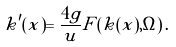<formula> <loc_0><loc_0><loc_500><loc_500>k ^ { \prime } ( x ) = \frac { 4 g } { u } F ( k ( x ) , \Omega ) \, .</formula> 